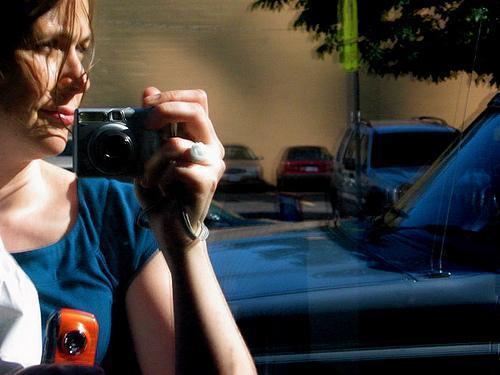How many cars can you see?
Give a very brief answer. 3. How many motorcycles can be seen?
Give a very brief answer. 0. 